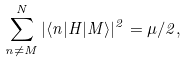Convert formula to latex. <formula><loc_0><loc_0><loc_500><loc_500>\sum _ { n \neq M } ^ { N } | \langle n | H | M \rangle | ^ { 2 } = \mu / 2 ,</formula> 